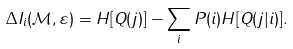<formula> <loc_0><loc_0><loc_500><loc_500>\Delta I _ { i } ( { \mathcal { M } } , \varepsilon ) = H [ Q ( j ) ] - \sum _ { i } P ( i ) H [ Q ( j | i ) ] .</formula> 